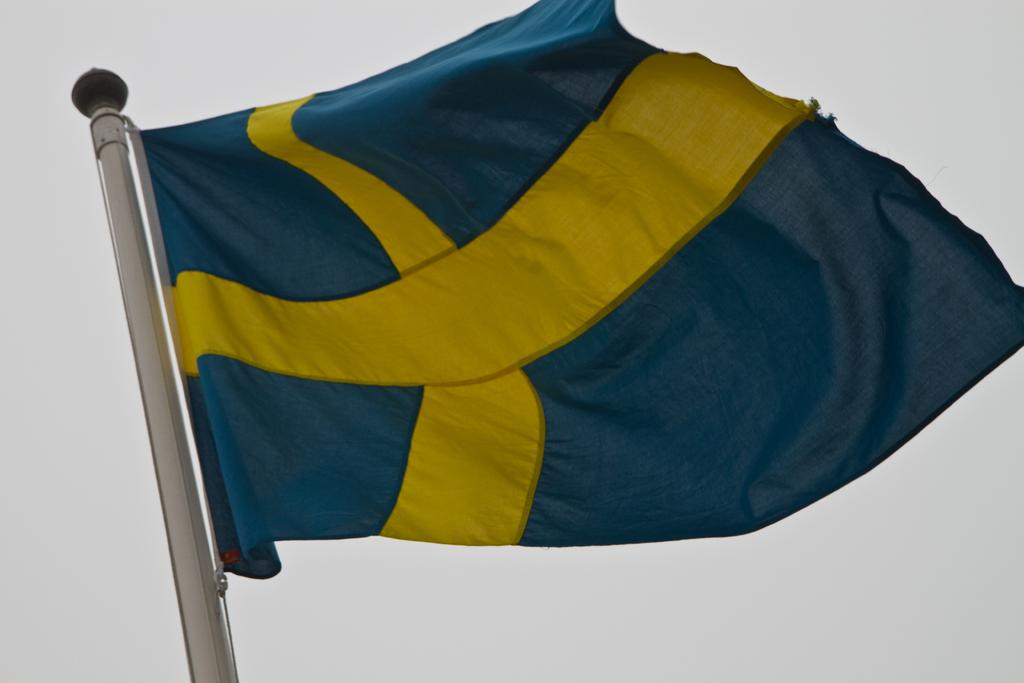What is present in the image that represents a symbol or country? There is a flag in the image. What can be seen in the background of the image? The sky is visible in the background of the image. What type of leather is being used to make the glass in the image? There is no glass or leather present in the image; it only features a flag and the sky in the background. 